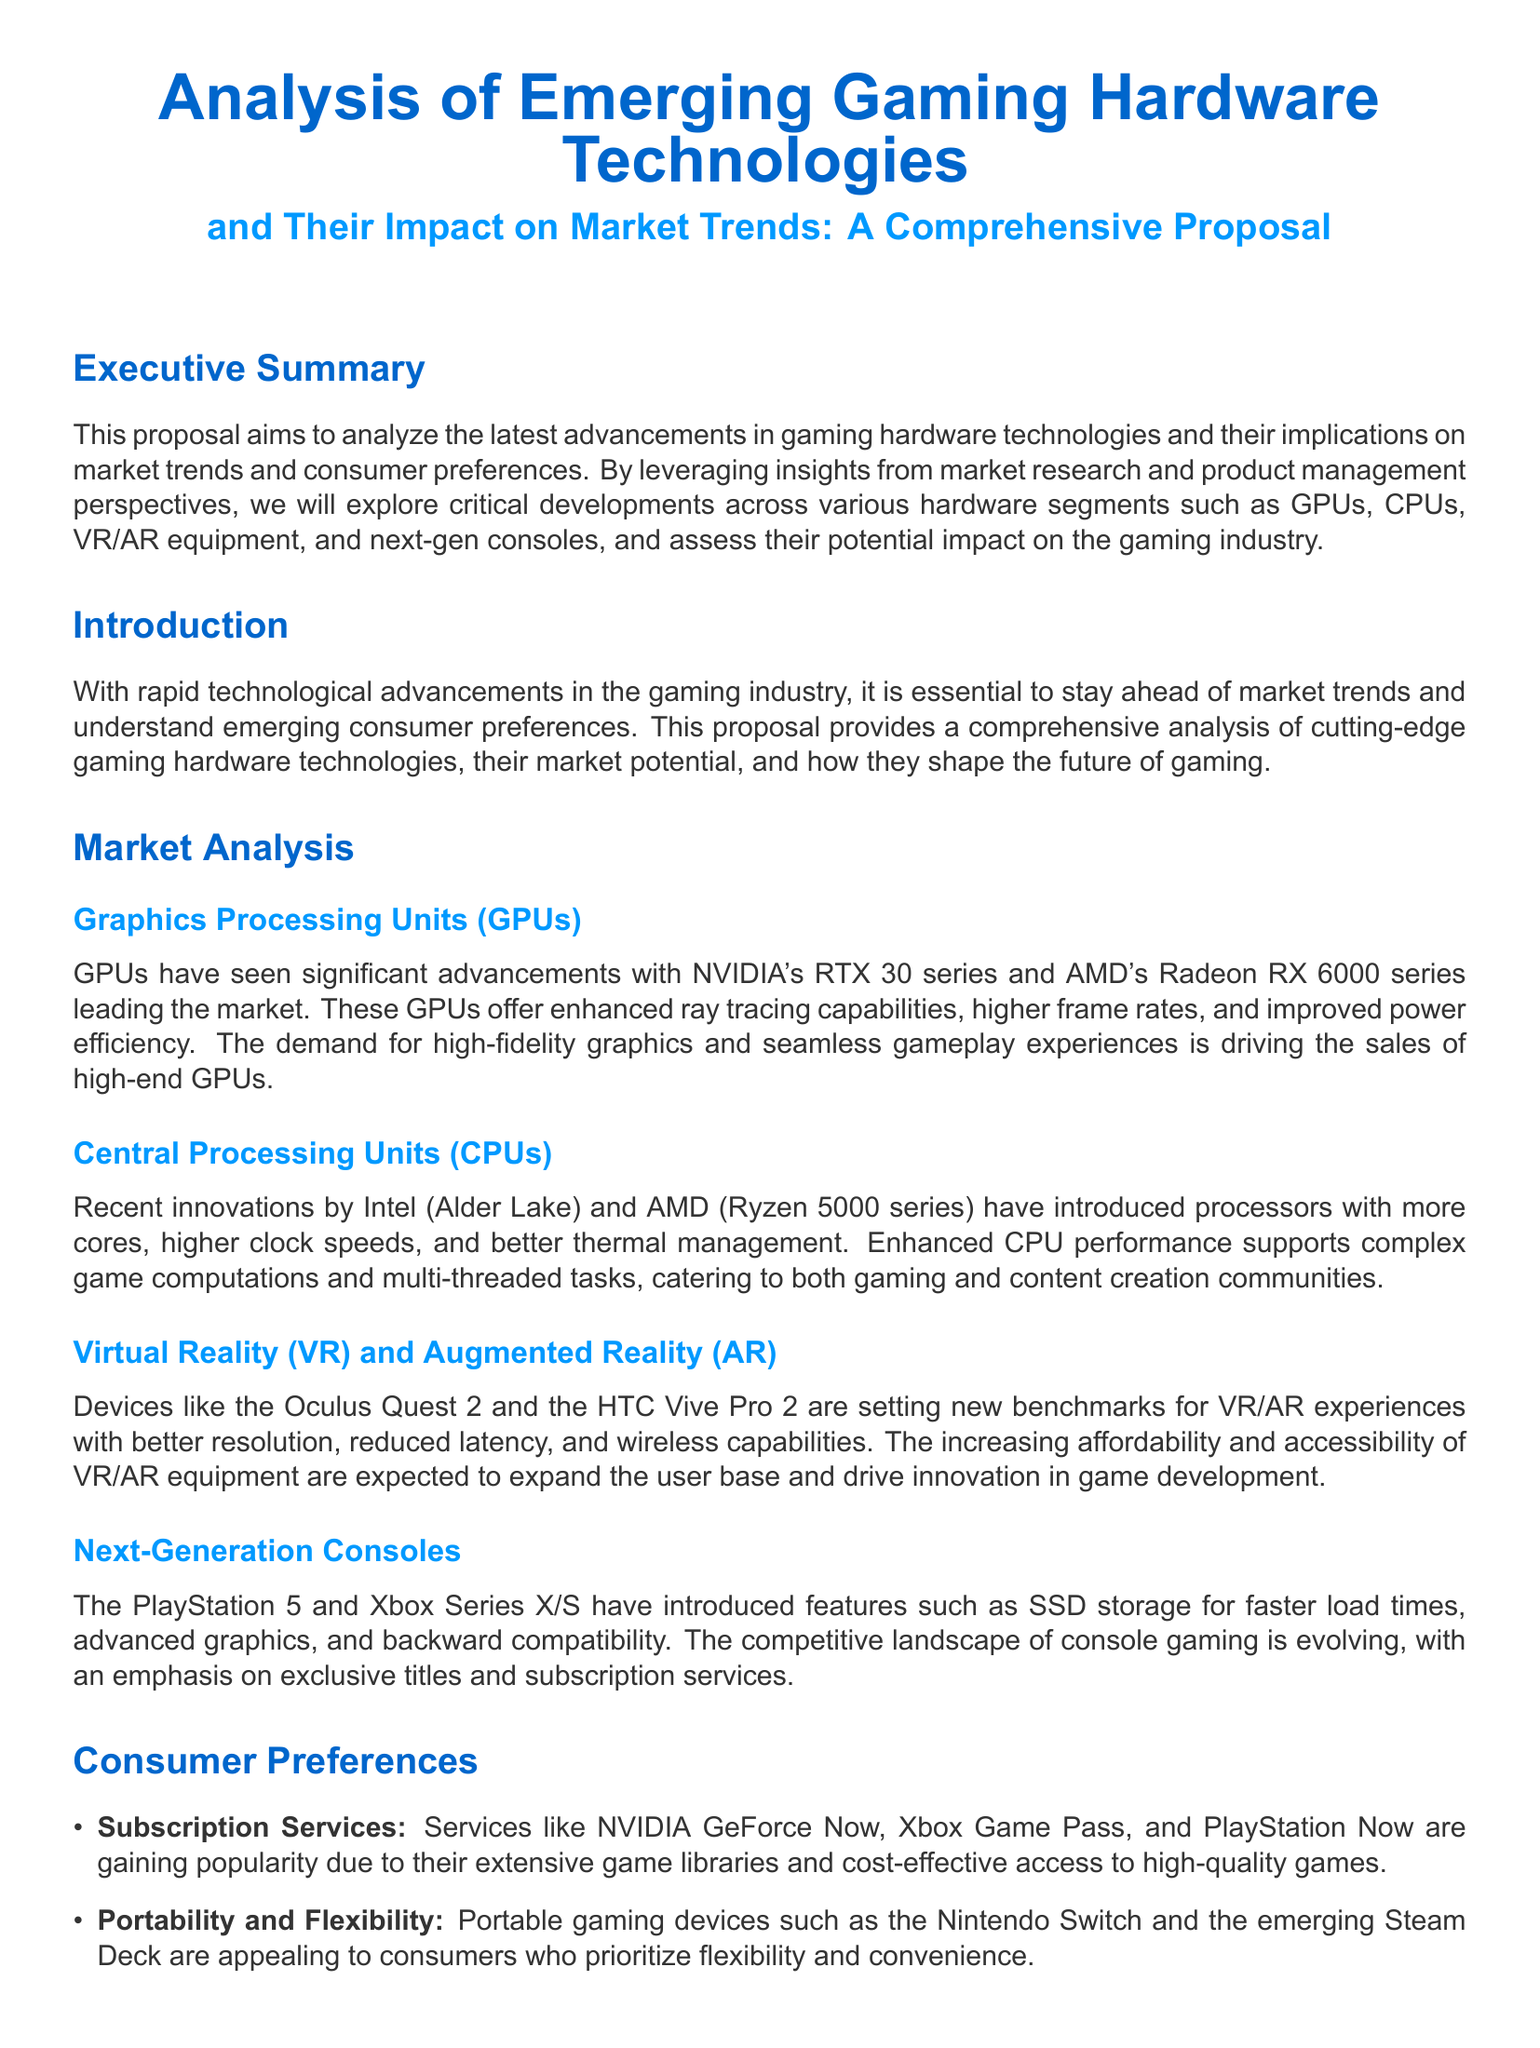What is the proposal's main focus? The main focus of the proposal is to analyze the latest advancements in gaming hardware technologies and their implications on market trends and consumer preferences.
Answer: gaming hardware technologies Which GPU series leads the market according to the document? The document states that NVIDIA's RTX 30 series and AMD's Radeon RX 6000 series lead the market.
Answer: RTX 30 series and Radeon RX 6000 series What feature has been highlighted for next-generation consoles? The document highlights SSD storage for faster load times as a feature for next-generation consoles.
Answer: SSD storage Which two companies are mentioned for their recent innovations in CPUs? The companies mentioned for their recent innovations in CPUs are Intel and AMD.
Answer: Intel and AMD What are two preferred consumer features in gaming devices mentioned? The document mentions Subscription Services and Portability and Flexibility as preferred consumer features.
Answer: Subscription Services and Portability and Flexibility What gaming devices are referred to as 'setting new benchmarks for VR/AR experiences'? The devices referred to are the Oculus Quest 2 and the HTC Vive Pro 2.
Answer: Oculus Quest 2 and HTC Vive Pro 2 What type of proposal is this document categorized as? The document is categorized as a proposal focused on market research in gaming hardware trends.
Answer: proposal What is the expected impact of VR/AR equipment on the user base? The document states that increasing affordability and accessibility of VR/AR equipment are expected to expand the user base.
Answer: expand the user base What aspect of consoles does the proposal emphasize regarding the competitive landscape? The proposal emphasizes exclusive titles and subscription services in the competitive landscape of console gaming.
Answer: exclusive titles and subscription services 